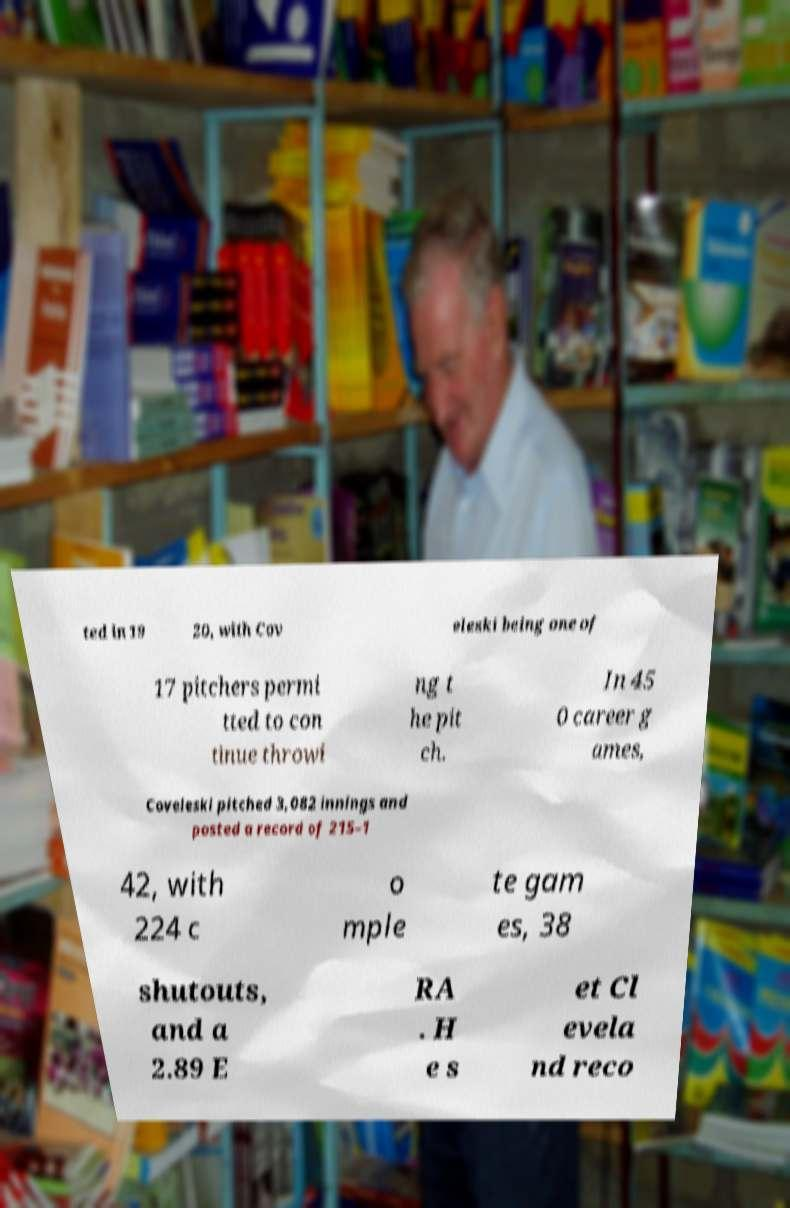Can you read and provide the text displayed in the image?This photo seems to have some interesting text. Can you extract and type it out for me? ted in 19 20, with Cov eleski being one of 17 pitchers permi tted to con tinue throwi ng t he pit ch. In 45 0 career g ames, Coveleski pitched 3,082 innings and posted a record of 215–1 42, with 224 c o mple te gam es, 38 shutouts, and a 2.89 E RA . H e s et Cl evela nd reco 